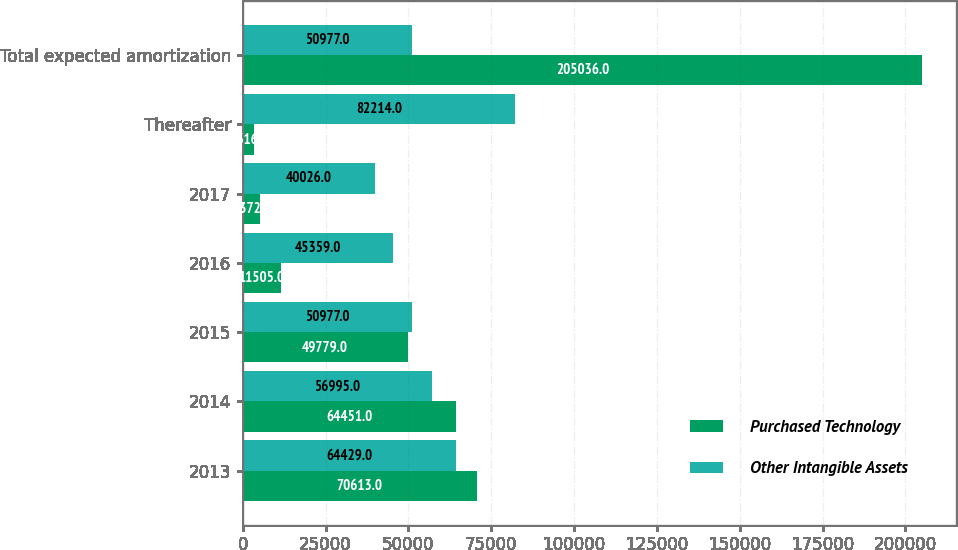Convert chart to OTSL. <chart><loc_0><loc_0><loc_500><loc_500><stacked_bar_chart><ecel><fcel>2013<fcel>2014<fcel>2015<fcel>2016<fcel>2017<fcel>Thereafter<fcel>Total expected amortization<nl><fcel>Purchased Technology<fcel>70613<fcel>64451<fcel>49779<fcel>11505<fcel>5372<fcel>3316<fcel>205036<nl><fcel>Other Intangible Assets<fcel>64429<fcel>56995<fcel>50977<fcel>45359<fcel>40026<fcel>82214<fcel>50977<nl></chart> 